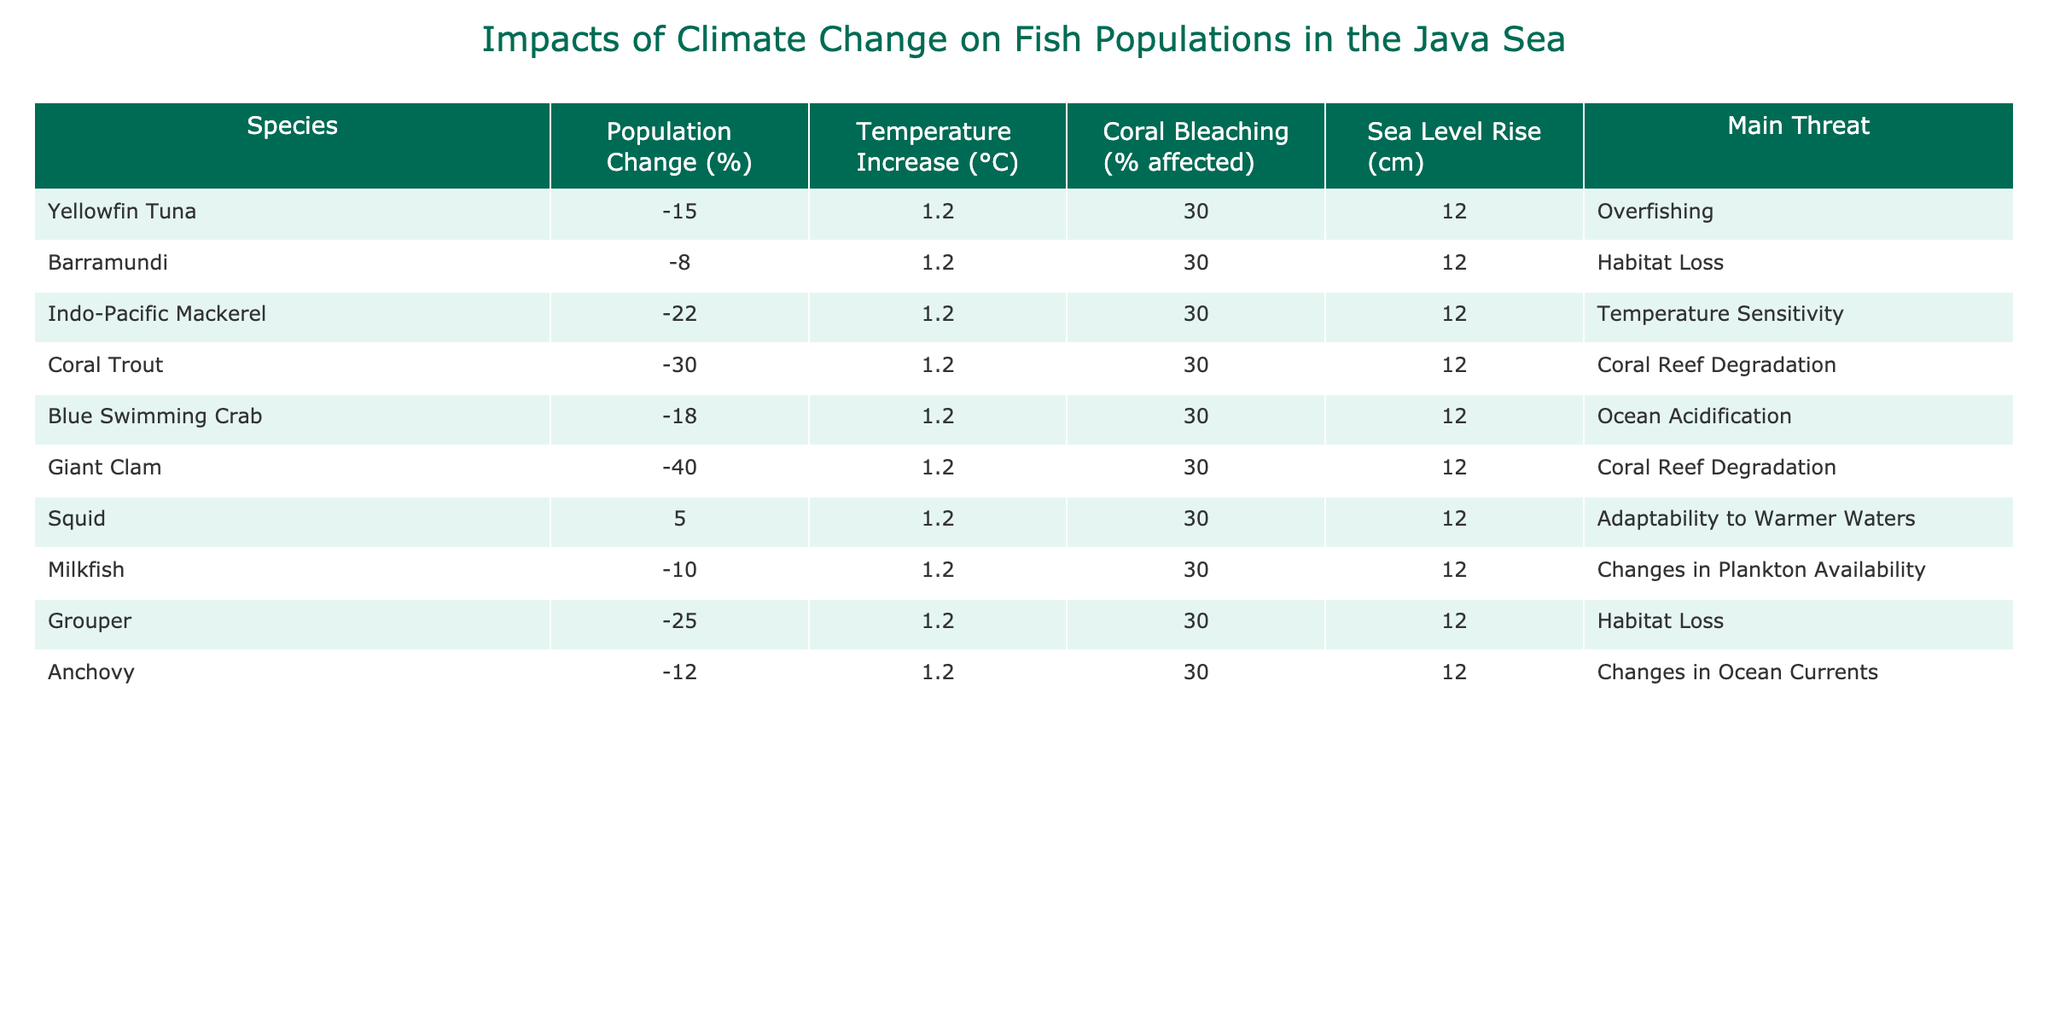What is the population change percentage of Yellowfin Tuna? The table lists Yellowfin Tuna with a population change of -15%.
Answer: -15% Which species has the highest population decline? By scanning the population change percentages, Giant Clam has the highest decline at -40%.
Answer: Giant Clam Is there any species experiencing a population increase? The table indicates Squid has a positive population change of +5%.
Answer: Yes, Squid What are the main threats to Indo-Pacific Mackerel? The table lists the main threat for Indo-Pacific Mackerel as Temperature Sensitivity.
Answer: Temperature Sensitivity How many species are affected by coral bleaching? All species listed in the table have a coral bleaching percentage of 30%, meaning all species are affected.
Answer: All species What is the average temperature increase for the species listed? Since all species have the same temperature increase of 1.2°C, the average is also 1.2°C.
Answer: 1.2°C Which species has the least impact from habitat loss? Comparing the main threats, Yellowfin Tuna is reported with Overfishing rather than Habitat Loss, indicating it has the least impact among the groups focused on habitat issues.
Answer: Yellowfin Tuna What is the total population change percentage of all species combined? The total can be calculated by summing the percentages: -15 + (-8) + (-22) + (-30) + (-18) + (-40) + 5 + (-10) + (-25) + (-12) = - 155%.
Answer: -155% Is there a correlation between population decline and main threats? Looking at the table, it appears that all species with significant declines have threats connected to environmental degradation or changing conditions, indicating a correlation.
Answer: Yes How many species are facing threats related to coral reef degradation? The table shows that Coral Trout and Giant Clam face threats from Coral Reef Degradation, totaling two species.
Answer: 2 species 